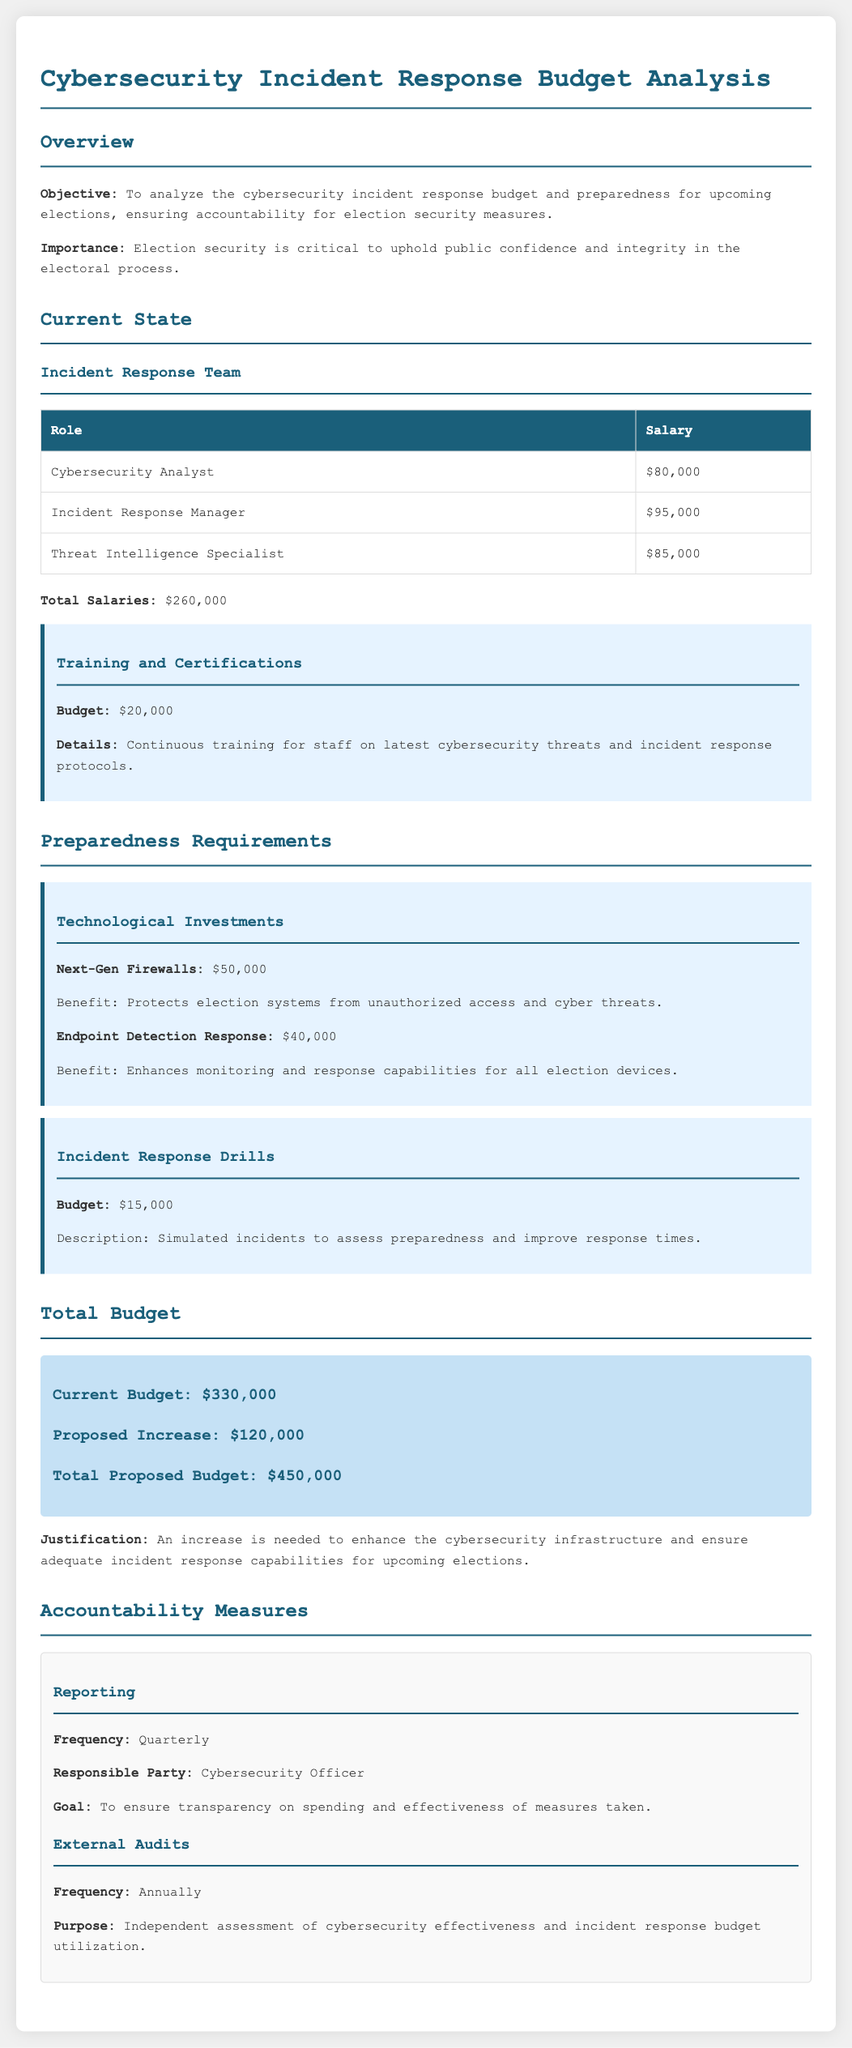what is the total salary for the incident response team? The total salary for the incident response team is calculated by summing the individual salaries listed: $80,000 + $95,000 + $85,000.
Answer: $260,000 what is the budget for training and certifications? The budget for training and certifications is explicitly mentioned in the document.
Answer: $20,000 what are the two technological investments listed? The technological investments listed include Next-Gen Firewalls and Endpoint Detection Response, both with specified costs.
Answer: Next-Gen Firewalls, Endpoint Detection Response what is the total proposed budget? The total proposed budget is mentioned in the budget section after accounting for the increase.
Answer: $450,000 who is responsible for the quarterly reporting? The document specifies which party is responsible for the reporting, linked to accountability measures.
Answer: Cybersecurity Officer what is the frequency of external audits? The document states how often external audits are conducted concerning accountability in the budget.
Answer: Annually why is an increase in the budget proposed? The justification for the proposed increase is provided in the total budget section, indicating a clear reason related to cybersecurity.
Answer: To enhance the cybersecurity infrastructure what is the total budget before the proposed increase? The current budget is detailed before any proposed changes are noted.
Answer: $330,000 how much is allocated for incident response drills? The budget allocation for this category is specifically mentioned in the preparedness requirements.
Answer: $15,000 